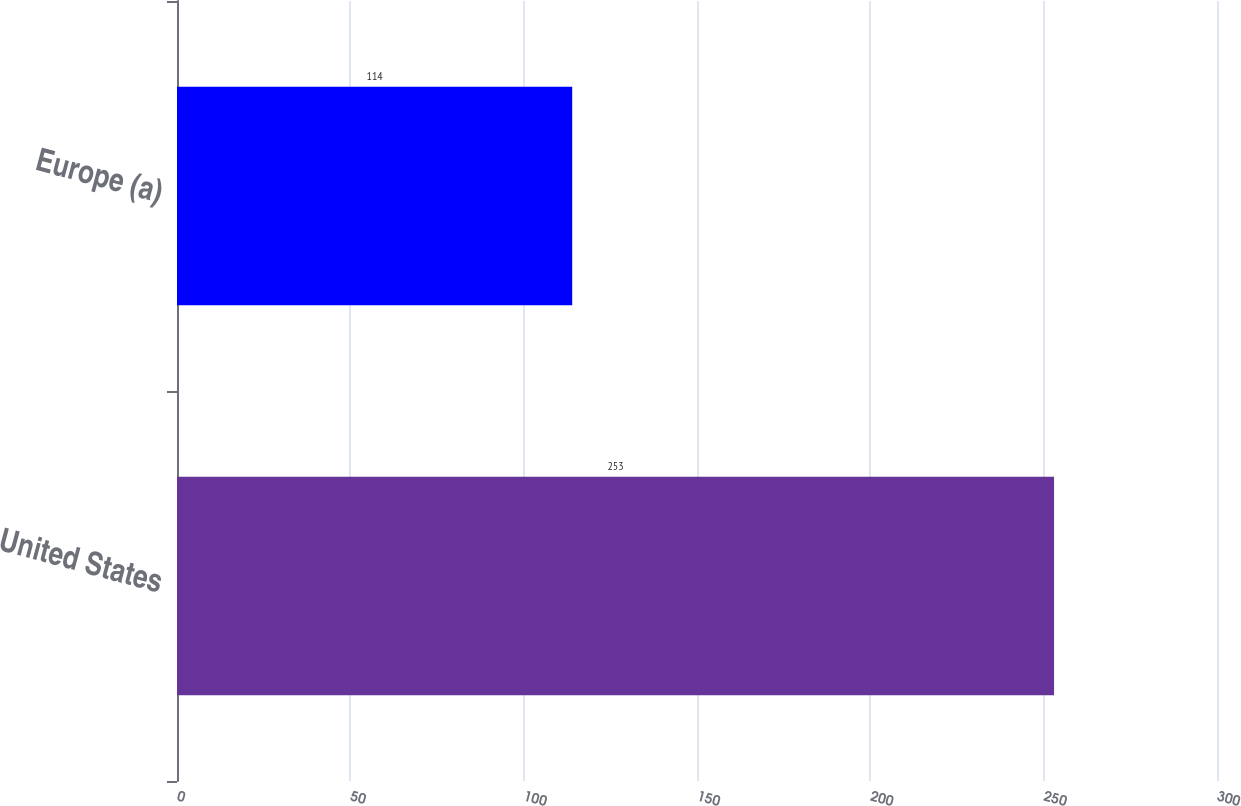<chart> <loc_0><loc_0><loc_500><loc_500><bar_chart><fcel>United States<fcel>Europe (a)<nl><fcel>253<fcel>114<nl></chart> 